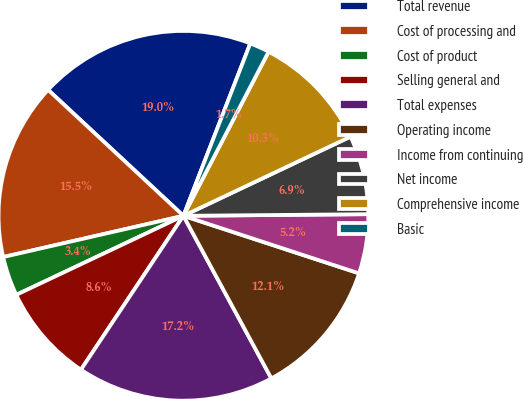Convert chart. <chart><loc_0><loc_0><loc_500><loc_500><pie_chart><fcel>Total revenue<fcel>Cost of processing and<fcel>Cost of product<fcel>Selling general and<fcel>Total expenses<fcel>Operating income<fcel>Income from continuing<fcel>Net income<fcel>Comprehensive income<fcel>Basic<nl><fcel>18.96%<fcel>15.51%<fcel>3.45%<fcel>8.62%<fcel>17.24%<fcel>12.07%<fcel>5.18%<fcel>6.9%<fcel>10.34%<fcel>1.73%<nl></chart> 